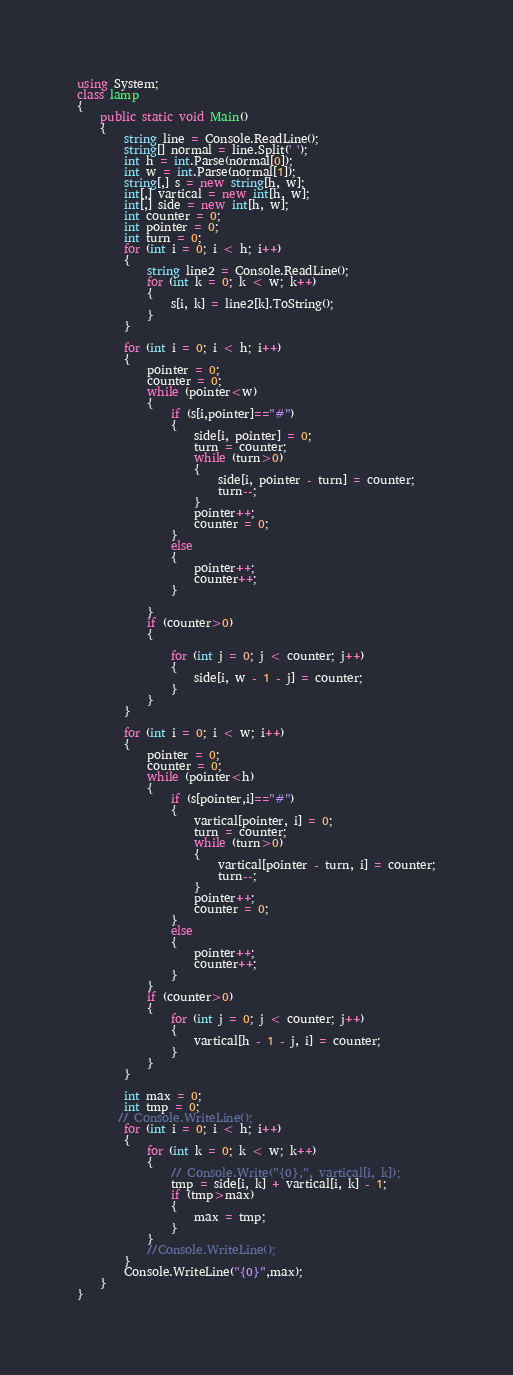Convert code to text. <code><loc_0><loc_0><loc_500><loc_500><_C#_>using System;
class lamp
{
    public static void Main()
    {
        string line = Console.ReadLine();
        string[] normal = line.Split(' ');
        int h = int.Parse(normal[0]);
        int w = int.Parse(normal[1]);
        string[,] s = new string[h, w];
        int[,] vartical = new int[h, w];
        int[,] side = new int[h, w];
        int counter = 0;
        int pointer = 0;
        int turn = 0;
        for (int i = 0; i < h; i++)
        {
            string line2 = Console.ReadLine();
            for (int k = 0; k < w; k++)
            {
                s[i, k] = line2[k].ToString();
            }
        }

        for (int i = 0; i < h; i++)
        {
            pointer = 0;
            counter = 0;
            while (pointer<w)
            {
                if (s[i,pointer]=="#")
                {
                    side[i, pointer] = 0;
                    turn = counter;
                    while (turn>0)
                    {
                        side[i, pointer - turn] = counter;
                        turn--;
                    }
                    pointer++;
                    counter = 0;
                }
                else
                {
                    pointer++;
                    counter++;
                }

            }
            if (counter>0)
            {
                
                for (int j = 0; j < counter; j++)
                {
                    side[i, w - 1 - j] = counter;
                }
            }
        }

        for (int i = 0; i < w; i++)
        {
            pointer = 0;
            counter = 0;
            while (pointer<h)
            {
                if (s[pointer,i]=="#")
                {
                    vartical[pointer, i] = 0;
                    turn = counter;
                    while (turn>0)
                    {
                        vartical[pointer - turn, i] = counter;
                        turn--;
                    }
                    pointer++;
                    counter = 0;
                }
                else
                {
                    pointer++;
                    counter++;
                }
            }
            if (counter>0)
            {
                for (int j = 0; j < counter; j++)
                {
                    vartical[h - 1 - j, i] = counter;
                }
            }
        }

        int max = 0;
        int tmp = 0;
       // Console.WriteLine();
        for (int i = 0; i < h; i++)
        {
            for (int k = 0; k < w; k++)
            {
                // Console.Write("{0},", vartical[i, k]);
                tmp = side[i, k] + vartical[i, k] - 1;
                if (tmp>max)
                {
                    max = tmp;
                }
            }
            //Console.WriteLine();
        }
        Console.WriteLine("{0}",max);
    }
}</code> 